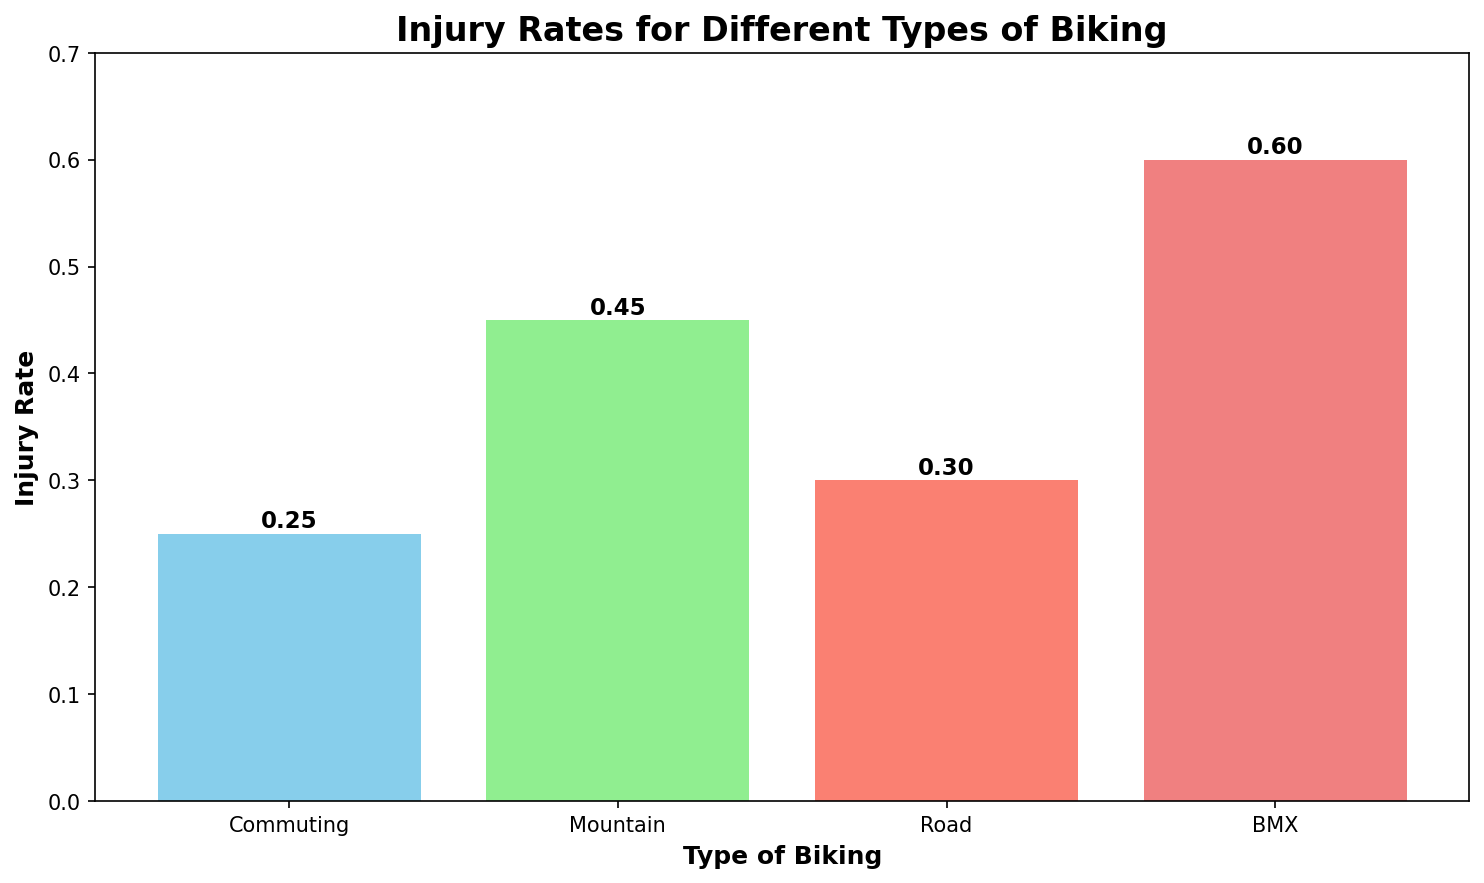What's the type of biking with the highest injury rate? The bar representing BMX biking is the tallest, indicating it has the highest injury rate at 0.60.
Answer: BMX What's the difference in injury rates between Mountain and Road biking? The injury rate for Mountain biking is 0.45, and for Road biking, it's 0.30. Subtracting these gives 0.45 - 0.30 = 0.15.
Answer: 0.15 Which type of biking has an injury rate less than 0.30? The injury rate for Commuting biking is 0.25, which is less than 0.30. All other types have injury rates of 0.30 or higher.
Answer: Commuting By how much is the injury rate for BMX biking higher than for Commuting biking? The injury rate for BMX biking is 0.60, and for Commuting biking, it is 0.25. The difference is 0.60 - 0.25 = 0.35.
Answer: 0.35 Which types of biking have injury rates greater than 0.40? Both Mountain biking and BMX biking have injury rates of 0.45 and 0.60, respectively, which are greater than 0.40.
Answer: Mountain, BMX What is the average injury rate across all types of biking? Add the injury rates: 0.25 (Commuting) + 0.45 (Mountain) + 0.30 (Road) + 0.60 (BMX) = 1.60. Divide by the number of types (4): 1.60 / 4 = 0.40.
Answer: 0.40 Rank the types of biking from the lowest to highest injury rate. Comparing the injury rates: Commuting (0.25), Road (0.30), Mountain (0.45), and BMX (0.60). The order from lowest to highest is: Commuting, Road, Mountain, BMX.
Answer: Commuting, Road, Mountain, BMX What color is used to represent Road biking? The bar for Road biking, the third one from the left, is colored salmon.
Answer: Salmon 